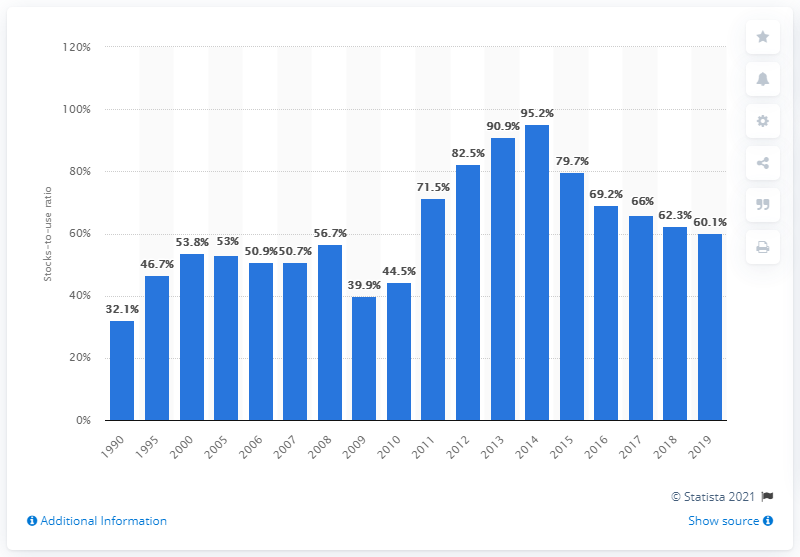Highlight a few significant elements in this photo. In 2017, the global cotton stocks-to-use ratio was 66%. 